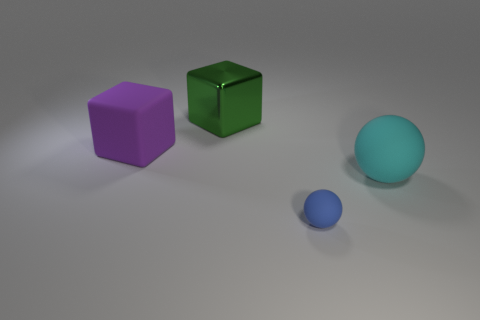What number of matte objects are either large purple things or large objects?
Your answer should be very brief. 2. What number of metal blocks are there?
Provide a succinct answer. 1. Is the sphere in front of the cyan ball made of the same material as the thing to the right of the blue sphere?
Provide a succinct answer. Yes. There is another big object that is the same shape as the large purple matte thing; what color is it?
Ensure brevity in your answer.  Green. There is a blue sphere on the right side of the green shiny block on the left side of the big cyan thing; what is it made of?
Your answer should be compact. Rubber. Does the matte object that is behind the cyan thing have the same shape as the object that is on the right side of the small ball?
Make the answer very short. No. There is a object that is both in front of the metallic cube and left of the small sphere; what is its size?
Your response must be concise. Large. How many other things are the same color as the big shiny thing?
Offer a terse response. 0. Do the big block that is behind the big purple block and the big cyan thing have the same material?
Your answer should be very brief. No. Is there anything else that is the same size as the blue rubber thing?
Provide a succinct answer. No. 